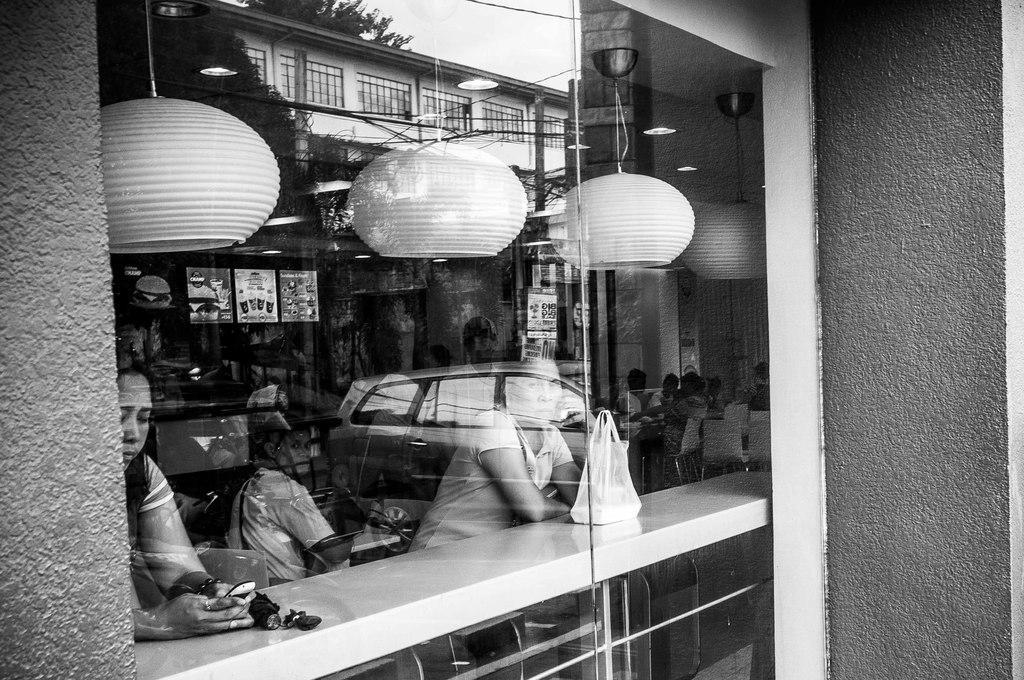Can you describe this image briefly? It is a black and white image, there is a window and inside the window there are few people and the picture of a vehicle is being reflected on the glass of the window. 